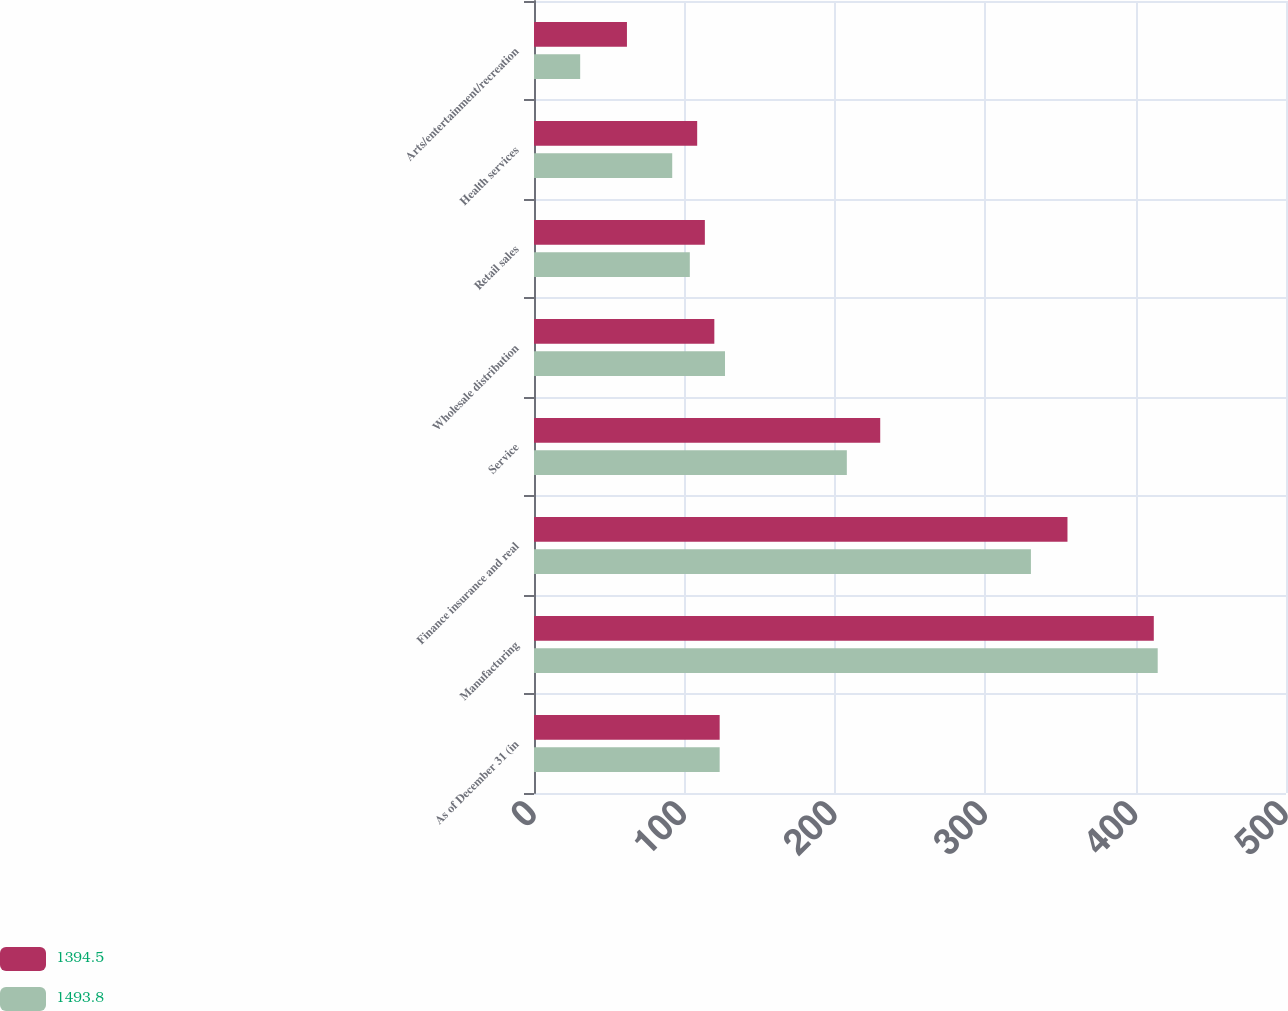<chart> <loc_0><loc_0><loc_500><loc_500><stacked_bar_chart><ecel><fcel>As of December 31 (in<fcel>Manufacturing<fcel>Finance insurance and real<fcel>Service<fcel>Wholesale distribution<fcel>Retail sales<fcel>Health services<fcel>Arts/entertainment/recreation<nl><fcel>1394.5<fcel>123.45<fcel>412.1<fcel>354.7<fcel>230.2<fcel>119.9<fcel>113.6<fcel>108.5<fcel>61.8<nl><fcel>1493.8<fcel>123.45<fcel>414.7<fcel>330.4<fcel>208<fcel>127<fcel>103.6<fcel>91.9<fcel>30.7<nl></chart> 